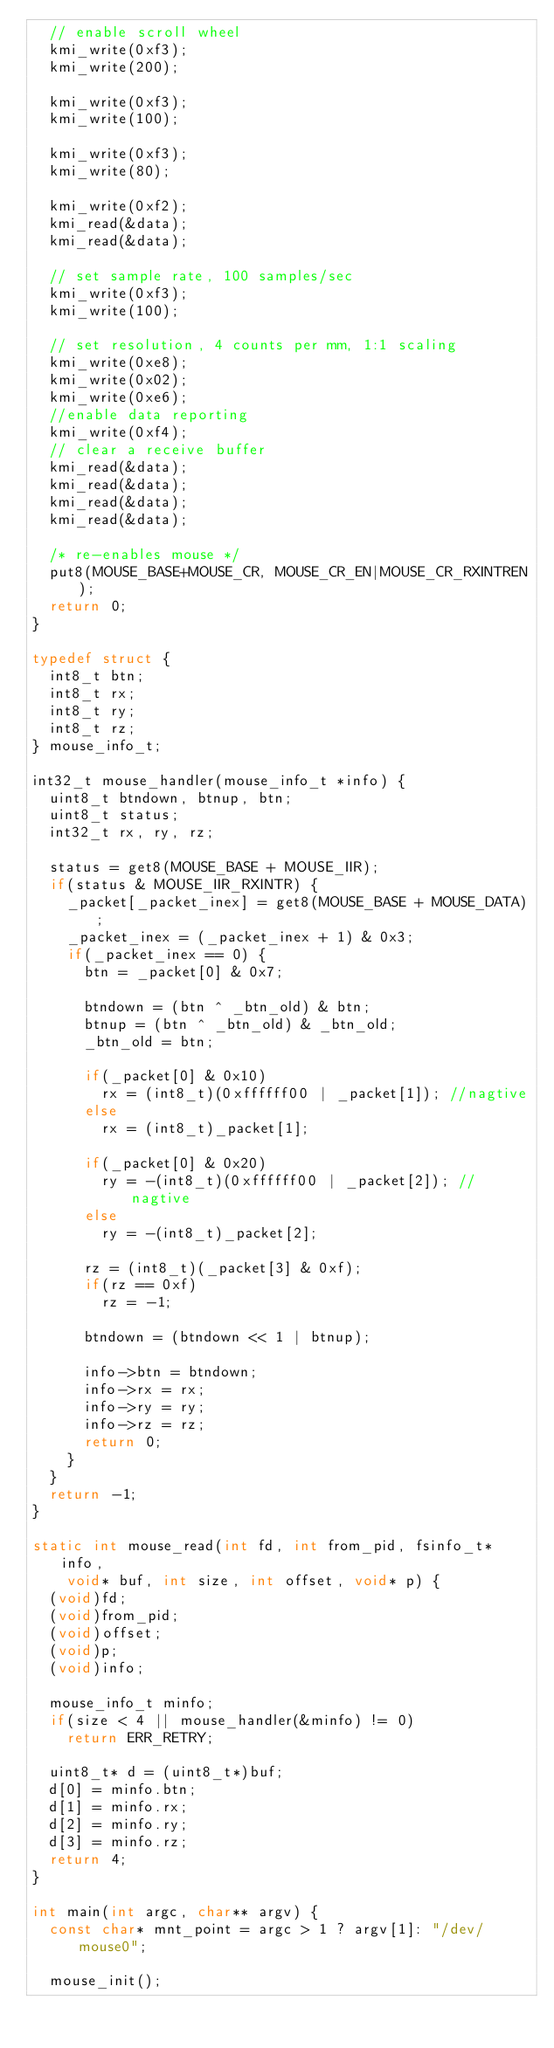<code> <loc_0><loc_0><loc_500><loc_500><_C_>	// enable scroll wheel
	kmi_write(0xf3);
	kmi_write(200);

	kmi_write(0xf3);
	kmi_write(100);

	kmi_write(0xf3);
	kmi_write(80);

	kmi_write(0xf2);
	kmi_read(&data);
	kmi_read(&data);

	// set sample rate, 100 samples/sec 
	kmi_write(0xf3);
	kmi_write(100);

	// set resolution, 4 counts per mm, 1:1 scaling
	kmi_write(0xe8);
	kmi_write(0x02);
	kmi_write(0xe6);
	//enable data reporting
	kmi_write(0xf4);
	// clear a receive buffer
	kmi_read(&data);
	kmi_read(&data);
	kmi_read(&data);
	kmi_read(&data);

	/* re-enables mouse */
  put8(MOUSE_BASE+MOUSE_CR, MOUSE_CR_EN|MOUSE_CR_RXINTREN); 
	return 0;
}

typedef struct {
	int8_t btn;
	int8_t rx;
	int8_t ry;
	int8_t rz;
} mouse_info_t;

int32_t mouse_handler(mouse_info_t *info) {
	uint8_t btndown, btnup, btn;
	uint8_t status;
	int32_t rx, ry, rz;

	status = get8(MOUSE_BASE + MOUSE_IIR);
	if(status & MOUSE_IIR_RXINTR) {
		_packet[_packet_inex] = get8(MOUSE_BASE + MOUSE_DATA);
		_packet_inex = (_packet_inex + 1) & 0x3;
		if(_packet_inex == 0) {
			btn = _packet[0] & 0x7;

			btndown = (btn ^ _btn_old) & btn;
			btnup = (btn ^ _btn_old) & _btn_old;
			_btn_old = btn;

			if(_packet[0] & 0x10)
				rx = (int8_t)(0xffffff00 | _packet[1]); //nagtive
			else
				rx = (int8_t)_packet[1];

			if(_packet[0] & 0x20)
				ry = -(int8_t)(0xffffff00 | _packet[2]); //nagtive
			else
				ry = -(int8_t)_packet[2];

			rz = (int8_t)(_packet[3] & 0xf);
			if(rz == 0xf)
				rz = -1;
			
			btndown = (btndown << 1 | btnup);

			info->btn = btndown;
			info->rx = rx;
			info->ry = ry;
			info->rz = rz;
			return 0;
		}
	}
	return -1;
}

static int mouse_read(int fd, int from_pid, fsinfo_t* info,
		void* buf, int size, int offset, void* p) {
	(void)fd;
	(void)from_pid;
	(void)offset;
	(void)p;
	(void)info;

	mouse_info_t minfo;
	if(size < 4 || mouse_handler(&minfo) != 0)
		return ERR_RETRY;

	uint8_t* d = (uint8_t*)buf;
	d[0] = minfo.btn;
	d[1] = minfo.rx;
	d[2] = minfo.ry;
	d[3] = minfo.rz;
	return 4;
}

int main(int argc, char** argv) {
	const char* mnt_point = argc > 1 ? argv[1]: "/dev/mouse0";

	mouse_init();</code> 